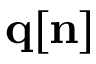<formula> <loc_0><loc_0><loc_500><loc_500>{ q } { [ n ] }</formula> 